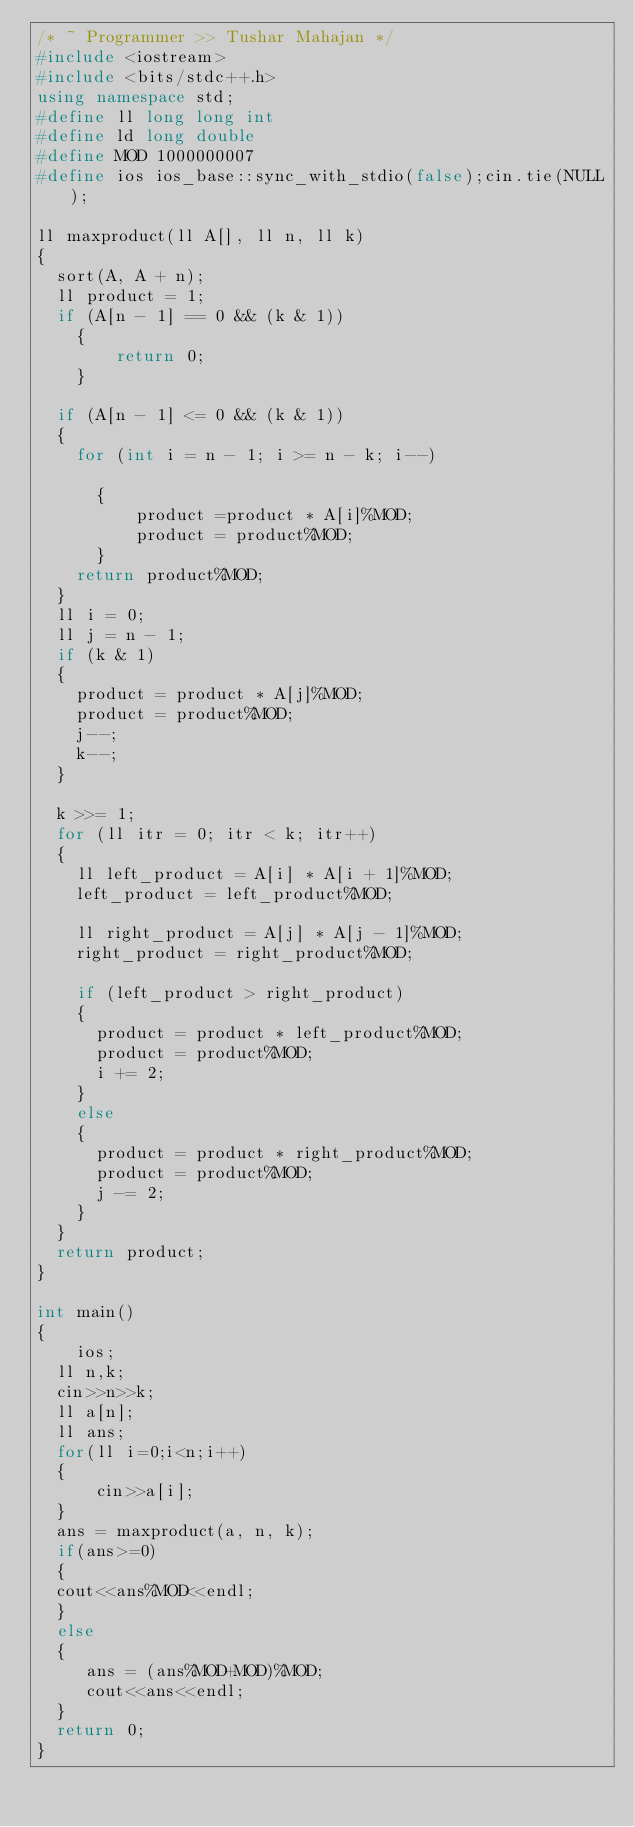Convert code to text. <code><loc_0><loc_0><loc_500><loc_500><_C++_>/* ~ Programmer >> Tushar Mahajan */
#include <iostream>
#include <bits/stdc++.h> 
using namespace std;
#define ll long long int
#define ld long double
#define MOD 1000000007
#define ios ios_base::sync_with_stdio(false);cin.tie(NULL); 

ll maxproduct(ll A[], ll n, ll k) 
{ 
	sort(A, A + n); 
	ll product = 1; 
	if (A[n - 1] == 0 && (k & 1)) 
		{
		    return 0;
		}

	if (A[n - 1] <= 0 && (k & 1)) 
	{ 
		for (int i = n - 1; i >= n - k; i--) 
			
			{
			    product =product * A[i]%MOD;
			    product = product%MOD;
			}
		return product%MOD; 
	} 
	ll i = 0; 
	ll j = n - 1; 
	if (k & 1) 
	{ 
		product = product * A[j]%MOD; 
		product = product%MOD;
		j--; 
		k--; 
	} 

	k >>= 1; 
	for (ll itr = 0; itr < k; itr++) 
	{ 
		ll left_product = A[i] * A[i + 1]%MOD;
		left_product = left_product%MOD;

		ll right_product = A[j] * A[j - 1]%MOD; 
		right_product = right_product%MOD;
		
		if (left_product > right_product) 
		{ 
			product = product * left_product%MOD;
			product = product%MOD;
			i += 2; 
		} 
		else 
		{ 
			product = product * right_product%MOD; 
			product = product%MOD;
			j -= 2; 
		} 
	} 
	return product; 
} 

int main() 
{ 
    ios;
	ll n,k;
	cin>>n>>k;
	ll a[n];
	ll ans;
	for(ll i=0;i<n;i++)
	{
	    cin>>a[i];
	}
	ans = maxproduct(a, n, k);
	if(ans>=0)
	{
	cout<<ans%MOD<<endl;
	}
	else
	{
	   ans = (ans%MOD+MOD)%MOD;
	   cout<<ans<<endl;
	}
	return 0; 
} 
</code> 